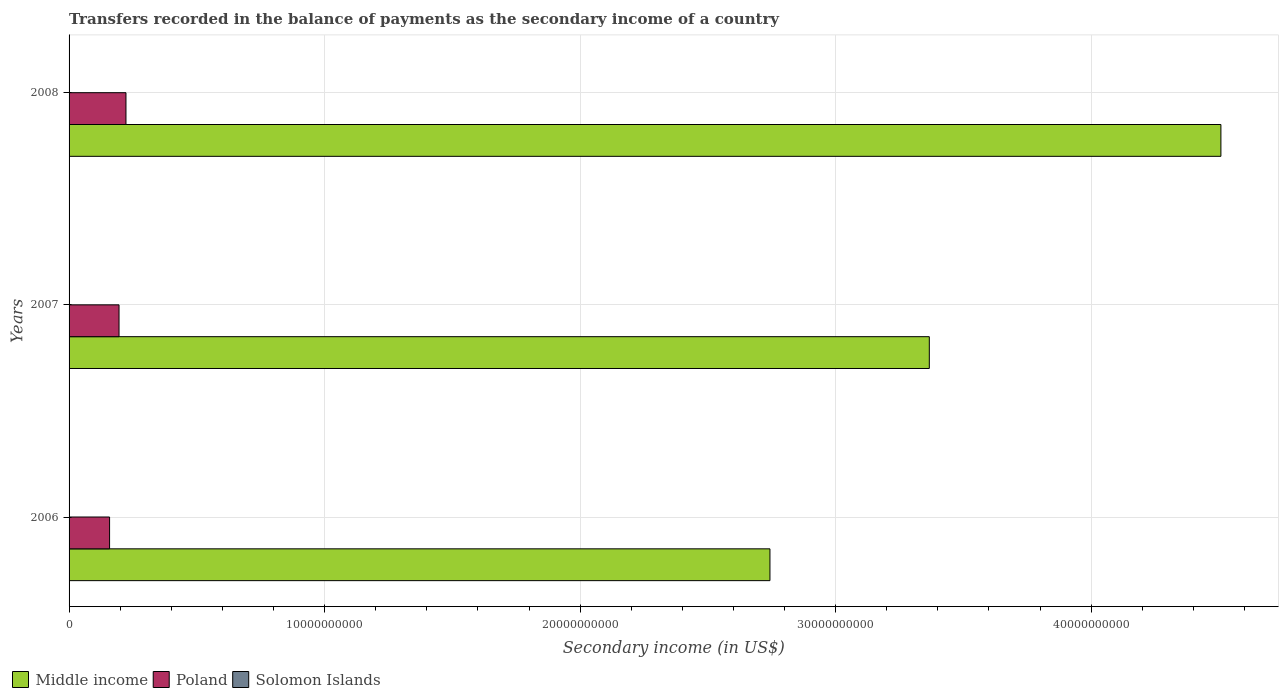How many bars are there on the 3rd tick from the top?
Your response must be concise. 3. What is the secondary income of in Solomon Islands in 2007?
Give a very brief answer. 8.44e+06. Across all years, what is the maximum secondary income of in Middle income?
Make the answer very short. 4.51e+1. Across all years, what is the minimum secondary income of in Poland?
Your answer should be compact. 1.58e+09. What is the total secondary income of in Middle income in the graph?
Your answer should be compact. 1.06e+11. What is the difference between the secondary income of in Middle income in 2006 and that in 2007?
Your response must be concise. -6.24e+09. What is the difference between the secondary income of in Middle income in 2006 and the secondary income of in Poland in 2007?
Give a very brief answer. 2.55e+1. What is the average secondary income of in Poland per year?
Your response must be concise. 1.92e+09. In the year 2008, what is the difference between the secondary income of in Solomon Islands and secondary income of in Middle income?
Provide a succinct answer. -4.51e+1. What is the ratio of the secondary income of in Middle income in 2006 to that in 2008?
Your response must be concise. 0.61. Is the difference between the secondary income of in Solomon Islands in 2006 and 2007 greater than the difference between the secondary income of in Middle income in 2006 and 2007?
Your answer should be compact. Yes. What is the difference between the highest and the second highest secondary income of in Middle income?
Provide a succinct answer. 1.14e+1. What is the difference between the highest and the lowest secondary income of in Poland?
Provide a short and direct response. 6.42e+08. Is the sum of the secondary income of in Middle income in 2007 and 2008 greater than the maximum secondary income of in Solomon Islands across all years?
Provide a short and direct response. Yes. What does the 1st bar from the bottom in 2008 represents?
Provide a succinct answer. Middle income. Is it the case that in every year, the sum of the secondary income of in Poland and secondary income of in Middle income is greater than the secondary income of in Solomon Islands?
Keep it short and to the point. Yes. How many bars are there?
Offer a very short reply. 9. Are all the bars in the graph horizontal?
Your answer should be compact. Yes. Does the graph contain any zero values?
Keep it short and to the point. No. Does the graph contain grids?
Keep it short and to the point. Yes. Where does the legend appear in the graph?
Provide a short and direct response. Bottom left. What is the title of the graph?
Provide a succinct answer. Transfers recorded in the balance of payments as the secondary income of a country. Does "Palau" appear as one of the legend labels in the graph?
Ensure brevity in your answer.  No. What is the label or title of the X-axis?
Offer a terse response. Secondary income (in US$). What is the label or title of the Y-axis?
Give a very brief answer. Years. What is the Secondary income (in US$) in Middle income in 2006?
Keep it short and to the point. 2.74e+1. What is the Secondary income (in US$) of Poland in 2006?
Offer a terse response. 1.58e+09. What is the Secondary income (in US$) of Solomon Islands in 2006?
Offer a very short reply. 9.36e+06. What is the Secondary income (in US$) in Middle income in 2007?
Offer a terse response. 3.37e+1. What is the Secondary income (in US$) in Poland in 2007?
Your answer should be very brief. 1.96e+09. What is the Secondary income (in US$) of Solomon Islands in 2007?
Your response must be concise. 8.44e+06. What is the Secondary income (in US$) in Middle income in 2008?
Ensure brevity in your answer.  4.51e+1. What is the Secondary income (in US$) of Poland in 2008?
Make the answer very short. 2.23e+09. What is the Secondary income (in US$) in Solomon Islands in 2008?
Your answer should be very brief. 1.14e+07. Across all years, what is the maximum Secondary income (in US$) in Middle income?
Your answer should be compact. 4.51e+1. Across all years, what is the maximum Secondary income (in US$) in Poland?
Your response must be concise. 2.23e+09. Across all years, what is the maximum Secondary income (in US$) in Solomon Islands?
Your answer should be compact. 1.14e+07. Across all years, what is the minimum Secondary income (in US$) in Middle income?
Ensure brevity in your answer.  2.74e+1. Across all years, what is the minimum Secondary income (in US$) in Poland?
Your answer should be compact. 1.58e+09. Across all years, what is the minimum Secondary income (in US$) in Solomon Islands?
Provide a short and direct response. 8.44e+06. What is the total Secondary income (in US$) of Middle income in the graph?
Provide a short and direct response. 1.06e+11. What is the total Secondary income (in US$) in Poland in the graph?
Offer a terse response. 5.77e+09. What is the total Secondary income (in US$) in Solomon Islands in the graph?
Give a very brief answer. 2.92e+07. What is the difference between the Secondary income (in US$) of Middle income in 2006 and that in 2007?
Make the answer very short. -6.24e+09. What is the difference between the Secondary income (in US$) in Poland in 2006 and that in 2007?
Ensure brevity in your answer.  -3.70e+08. What is the difference between the Secondary income (in US$) in Solomon Islands in 2006 and that in 2007?
Provide a succinct answer. 9.17e+05. What is the difference between the Secondary income (in US$) in Middle income in 2006 and that in 2008?
Make the answer very short. -1.76e+1. What is the difference between the Secondary income (in US$) of Poland in 2006 and that in 2008?
Keep it short and to the point. -6.42e+08. What is the difference between the Secondary income (in US$) in Solomon Islands in 2006 and that in 2008?
Your answer should be very brief. -2.03e+06. What is the difference between the Secondary income (in US$) in Middle income in 2007 and that in 2008?
Provide a short and direct response. -1.14e+1. What is the difference between the Secondary income (in US$) in Poland in 2007 and that in 2008?
Make the answer very short. -2.72e+08. What is the difference between the Secondary income (in US$) in Solomon Islands in 2007 and that in 2008?
Your answer should be very brief. -2.95e+06. What is the difference between the Secondary income (in US$) of Middle income in 2006 and the Secondary income (in US$) of Poland in 2007?
Provide a succinct answer. 2.55e+1. What is the difference between the Secondary income (in US$) of Middle income in 2006 and the Secondary income (in US$) of Solomon Islands in 2007?
Make the answer very short. 2.74e+1. What is the difference between the Secondary income (in US$) in Poland in 2006 and the Secondary income (in US$) in Solomon Islands in 2007?
Make the answer very short. 1.58e+09. What is the difference between the Secondary income (in US$) in Middle income in 2006 and the Secondary income (in US$) in Poland in 2008?
Give a very brief answer. 2.52e+1. What is the difference between the Secondary income (in US$) in Middle income in 2006 and the Secondary income (in US$) in Solomon Islands in 2008?
Your answer should be very brief. 2.74e+1. What is the difference between the Secondary income (in US$) in Poland in 2006 and the Secondary income (in US$) in Solomon Islands in 2008?
Keep it short and to the point. 1.57e+09. What is the difference between the Secondary income (in US$) in Middle income in 2007 and the Secondary income (in US$) in Poland in 2008?
Keep it short and to the point. 3.14e+1. What is the difference between the Secondary income (in US$) in Middle income in 2007 and the Secondary income (in US$) in Solomon Islands in 2008?
Ensure brevity in your answer.  3.37e+1. What is the difference between the Secondary income (in US$) of Poland in 2007 and the Secondary income (in US$) of Solomon Islands in 2008?
Ensure brevity in your answer.  1.94e+09. What is the average Secondary income (in US$) in Middle income per year?
Your answer should be compact. 3.54e+1. What is the average Secondary income (in US$) of Poland per year?
Ensure brevity in your answer.  1.92e+09. What is the average Secondary income (in US$) in Solomon Islands per year?
Provide a succinct answer. 9.73e+06. In the year 2006, what is the difference between the Secondary income (in US$) in Middle income and Secondary income (in US$) in Poland?
Give a very brief answer. 2.58e+1. In the year 2006, what is the difference between the Secondary income (in US$) in Middle income and Secondary income (in US$) in Solomon Islands?
Ensure brevity in your answer.  2.74e+1. In the year 2006, what is the difference between the Secondary income (in US$) of Poland and Secondary income (in US$) of Solomon Islands?
Offer a terse response. 1.58e+09. In the year 2007, what is the difference between the Secondary income (in US$) of Middle income and Secondary income (in US$) of Poland?
Make the answer very short. 3.17e+1. In the year 2007, what is the difference between the Secondary income (in US$) in Middle income and Secondary income (in US$) in Solomon Islands?
Your answer should be very brief. 3.37e+1. In the year 2007, what is the difference between the Secondary income (in US$) of Poland and Secondary income (in US$) of Solomon Islands?
Your answer should be compact. 1.95e+09. In the year 2008, what is the difference between the Secondary income (in US$) of Middle income and Secondary income (in US$) of Poland?
Offer a very short reply. 4.29e+1. In the year 2008, what is the difference between the Secondary income (in US$) of Middle income and Secondary income (in US$) of Solomon Islands?
Provide a succinct answer. 4.51e+1. In the year 2008, what is the difference between the Secondary income (in US$) in Poland and Secondary income (in US$) in Solomon Islands?
Make the answer very short. 2.22e+09. What is the ratio of the Secondary income (in US$) of Middle income in 2006 to that in 2007?
Offer a terse response. 0.81. What is the ratio of the Secondary income (in US$) in Poland in 2006 to that in 2007?
Provide a short and direct response. 0.81. What is the ratio of the Secondary income (in US$) in Solomon Islands in 2006 to that in 2007?
Provide a succinct answer. 1.11. What is the ratio of the Secondary income (in US$) of Middle income in 2006 to that in 2008?
Keep it short and to the point. 0.61. What is the ratio of the Secondary income (in US$) in Poland in 2006 to that in 2008?
Make the answer very short. 0.71. What is the ratio of the Secondary income (in US$) of Solomon Islands in 2006 to that in 2008?
Keep it short and to the point. 0.82. What is the ratio of the Secondary income (in US$) of Middle income in 2007 to that in 2008?
Ensure brevity in your answer.  0.75. What is the ratio of the Secondary income (in US$) in Poland in 2007 to that in 2008?
Provide a short and direct response. 0.88. What is the ratio of the Secondary income (in US$) of Solomon Islands in 2007 to that in 2008?
Your answer should be very brief. 0.74. What is the difference between the highest and the second highest Secondary income (in US$) of Middle income?
Offer a terse response. 1.14e+1. What is the difference between the highest and the second highest Secondary income (in US$) in Poland?
Make the answer very short. 2.72e+08. What is the difference between the highest and the second highest Secondary income (in US$) in Solomon Islands?
Give a very brief answer. 2.03e+06. What is the difference between the highest and the lowest Secondary income (in US$) of Middle income?
Keep it short and to the point. 1.76e+1. What is the difference between the highest and the lowest Secondary income (in US$) in Poland?
Provide a short and direct response. 6.42e+08. What is the difference between the highest and the lowest Secondary income (in US$) of Solomon Islands?
Keep it short and to the point. 2.95e+06. 